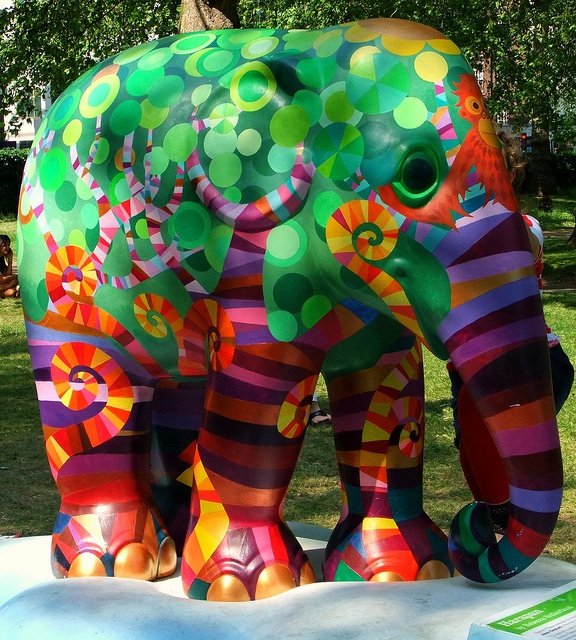Describe the objects in this image and their specific colors. I can see elephant in beige, black, maroon, darkgreen, and green tones, people in ivory, black, and gray tones, and traffic light in beige, black, maroon, salmon, and brown tones in this image. 